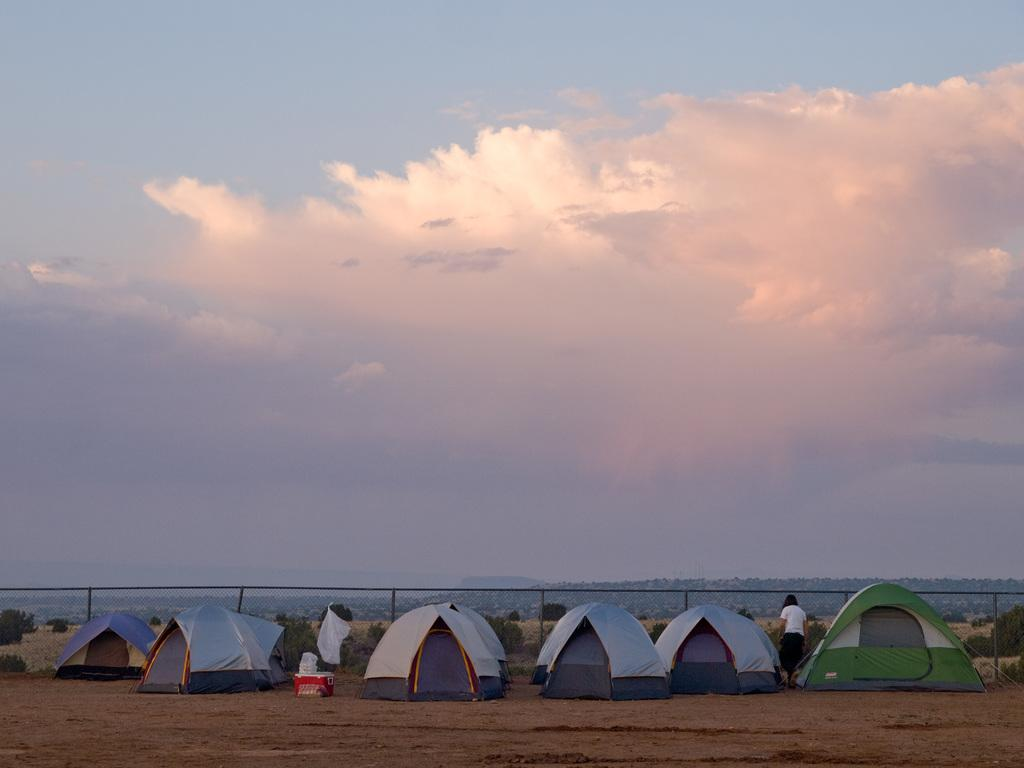What can be seen in the sky in the image? The sky with clouds is visible in the image. What type of vegetation is present in the image? There are trees in the image. What object is used for cooking in the image? A grill is present in the image. Who is in the image besides the trees and the grill? There is a person standing on the ground in the image. What type of temporary shelter is visible in the image? Tents are visible in the image. Can you tell me how many kitties are playing with the company in the image? There are no kitties or any reference to a company present in the image. 